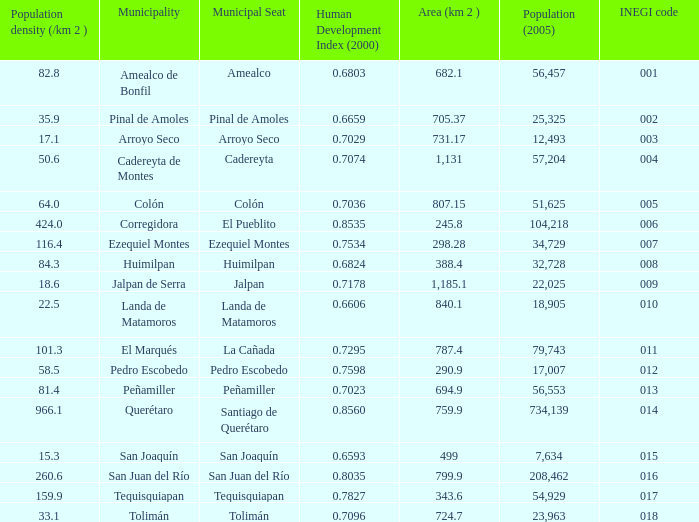WHat is the amount of Human Development Index (2000) that has a Population (2005) of 54,929, and an Area (km 2 ) larger than 343.6? 0.0. 